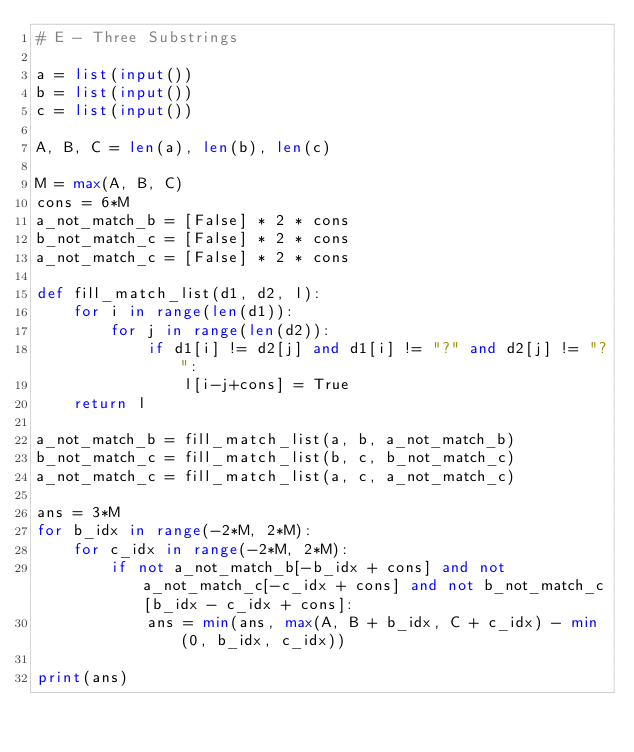Convert code to text. <code><loc_0><loc_0><loc_500><loc_500><_Python_># E - Three Substrings

a = list(input())
b = list(input())
c = list(input())

A, B, C = len(a), len(b), len(c)

M = max(A, B, C)
cons = 6*M
a_not_match_b = [False] * 2 * cons
b_not_match_c = [False] * 2 * cons
a_not_match_c = [False] * 2 * cons

def fill_match_list(d1, d2, l):
    for i in range(len(d1)):
        for j in range(len(d2)):
            if d1[i] != d2[j] and d1[i] != "?" and d2[j] != "?":
                l[i-j+cons] = True
    return l

a_not_match_b = fill_match_list(a, b, a_not_match_b)
b_not_match_c = fill_match_list(b, c, b_not_match_c)
a_not_match_c = fill_match_list(a, c, a_not_match_c)

ans = 3*M
for b_idx in range(-2*M, 2*M):
    for c_idx in range(-2*M, 2*M):
        if not a_not_match_b[-b_idx + cons] and not a_not_match_c[-c_idx + cons] and not b_not_match_c[b_idx - c_idx + cons]:
            ans = min(ans, max(A, B + b_idx, C + c_idx) - min(0, b_idx, c_idx))

print(ans)</code> 